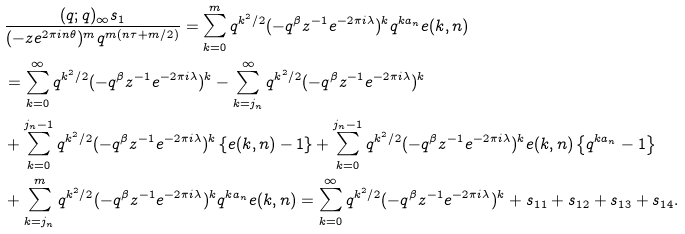<formula> <loc_0><loc_0><loc_500><loc_500>& \frac { ( q ; q ) _ { \infty } s _ { 1 } } { ( - z e ^ { 2 \pi i n \theta } ) ^ { m } q ^ { m ( n \tau + m / 2 ) } } = \sum _ { k = 0 } ^ { m } q ^ { k ^ { 2 } / 2 } ( - q ^ { \beta } z ^ { - 1 } e ^ { - 2 \pi i \lambda } ) ^ { k } q ^ { k a _ { n } } e ( k , n ) \\ & = \sum _ { k = 0 } ^ { \infty } q ^ { k ^ { 2 } / 2 } ( - q ^ { \beta } z ^ { - 1 } e ^ { - 2 \pi i \lambda } ) ^ { k } - \sum _ { k = j _ { n } } ^ { \infty } q ^ { k ^ { 2 } / 2 } ( - q ^ { \beta } z ^ { - 1 } e ^ { - 2 \pi i \lambda } ) ^ { k } \\ & + \sum _ { k = 0 } ^ { j _ { n } - 1 } q ^ { k ^ { 2 } / 2 } ( - q ^ { \beta } z ^ { - 1 } e ^ { - 2 \pi i \lambda } ) ^ { k } \left \{ e ( k , n ) - 1 \right \} + \sum _ { k = 0 } ^ { j _ { n } - 1 } q ^ { k ^ { 2 } / 2 } ( - q ^ { \beta } z ^ { - 1 } e ^ { - 2 \pi i \lambda } ) ^ { k } e ( k , n ) \left \{ q ^ { k a _ { n } } - 1 \right \} \\ & + \sum _ { k = j _ { n } } ^ { m } q ^ { k ^ { 2 } / 2 } ( - q ^ { \beta } z ^ { - 1 } e ^ { - 2 \pi i \lambda } ) ^ { k } q ^ { k a _ { n } } e ( k , n ) = \sum _ { k = 0 } ^ { \infty } q ^ { k ^ { 2 } / 2 } ( - q ^ { \beta } z ^ { - 1 } e ^ { - 2 \pi i \lambda } ) ^ { k } + s _ { 1 1 } + s _ { 1 2 } + s _ { 1 3 } + s _ { 1 4 } .</formula> 